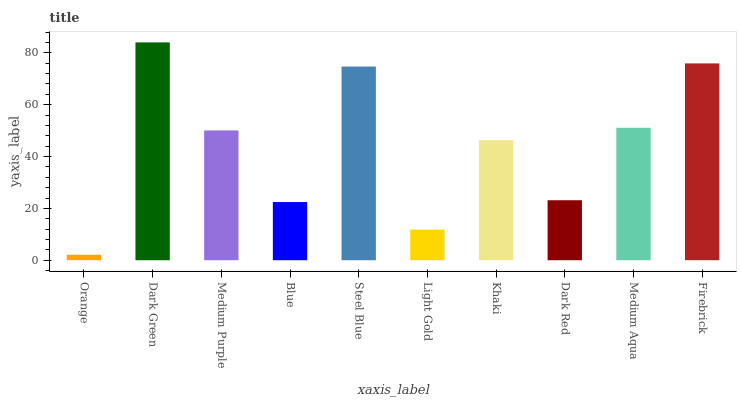Is Medium Purple the minimum?
Answer yes or no. No. Is Medium Purple the maximum?
Answer yes or no. No. Is Dark Green greater than Medium Purple?
Answer yes or no. Yes. Is Medium Purple less than Dark Green?
Answer yes or no. Yes. Is Medium Purple greater than Dark Green?
Answer yes or no. No. Is Dark Green less than Medium Purple?
Answer yes or no. No. Is Medium Purple the high median?
Answer yes or no. Yes. Is Khaki the low median?
Answer yes or no. Yes. Is Khaki the high median?
Answer yes or no. No. Is Dark Green the low median?
Answer yes or no. No. 